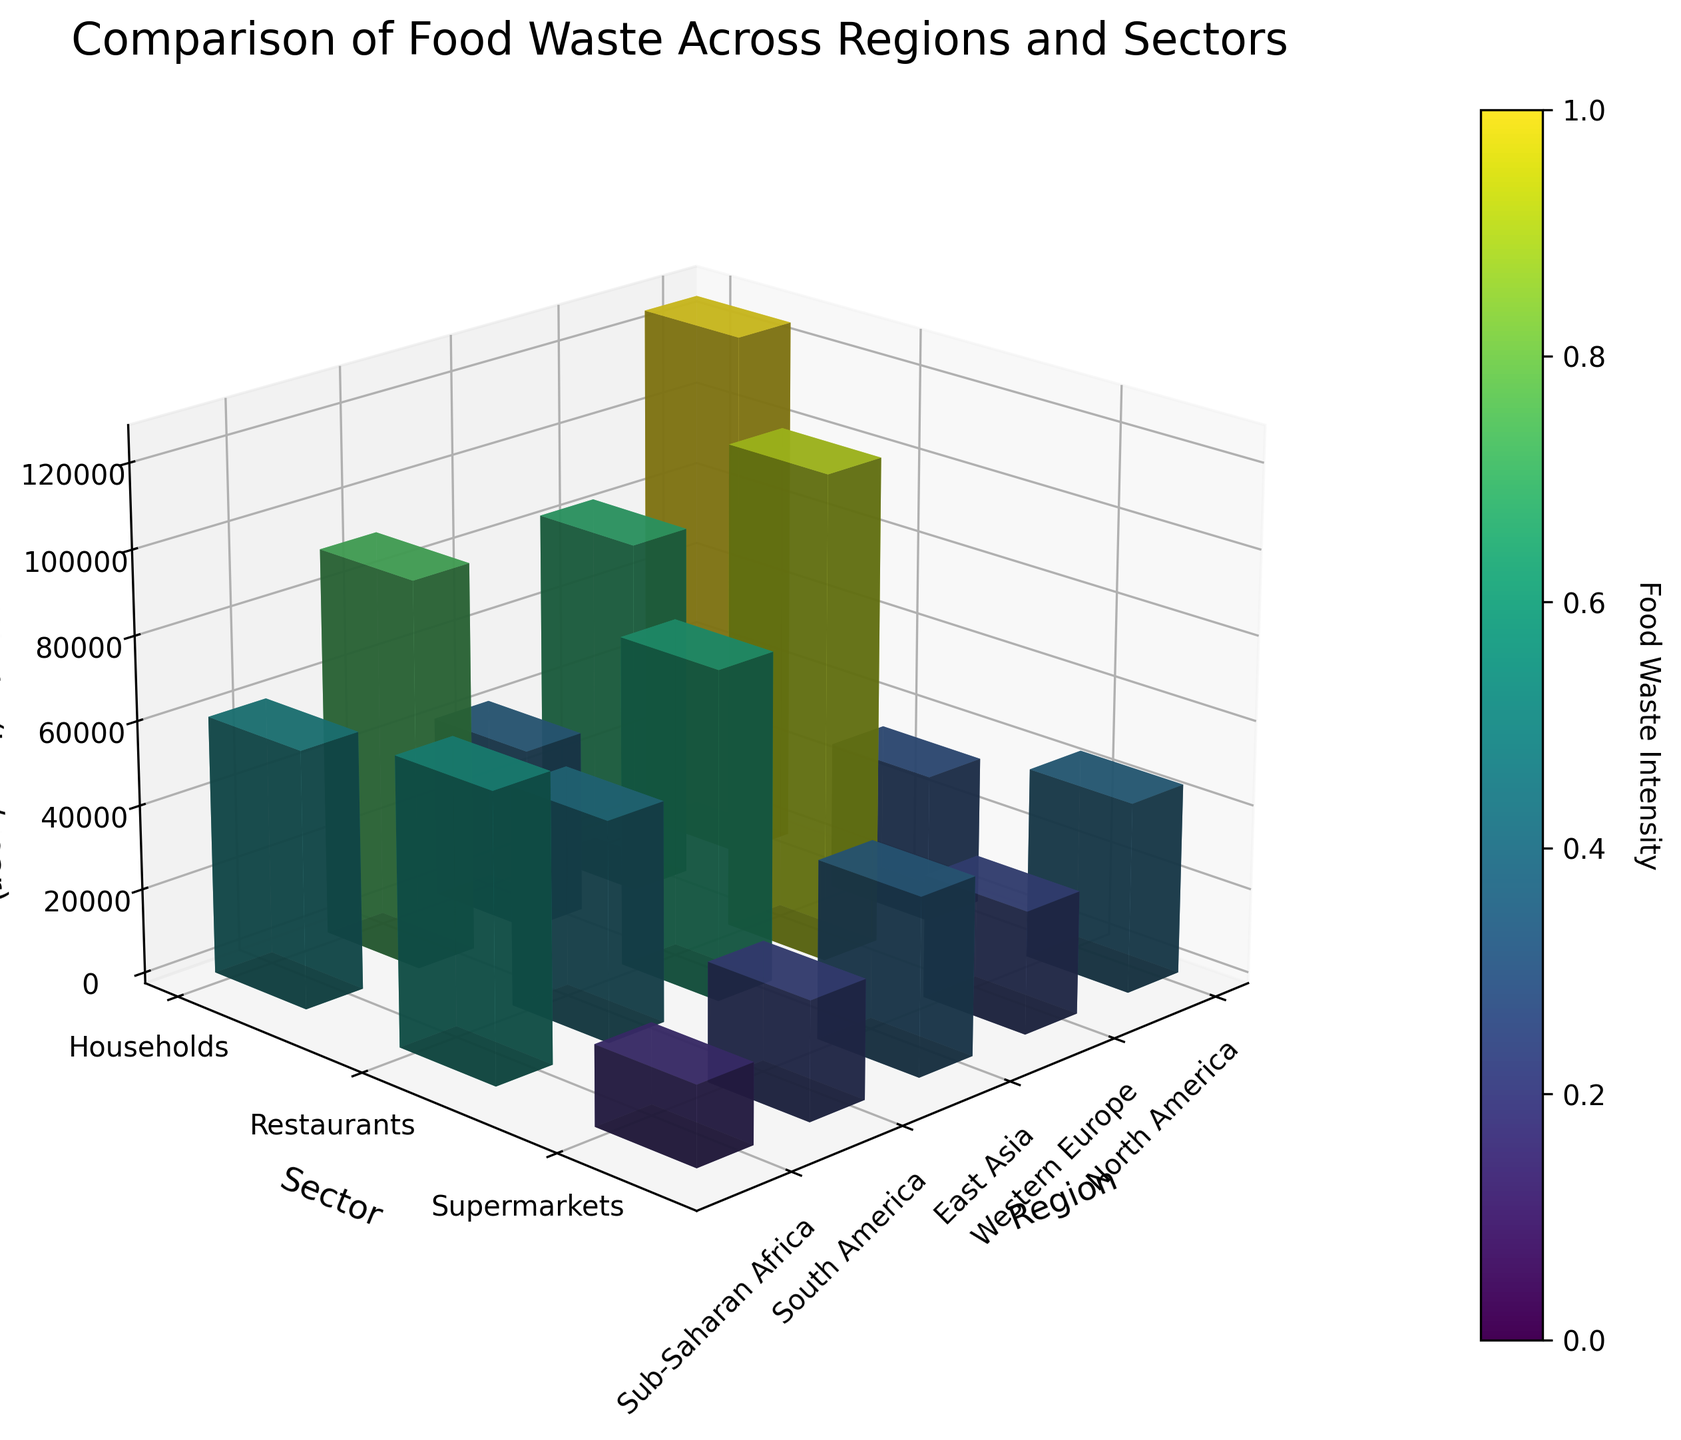Which sector in North America has the highest food waste? By examining the bars representing North America, the highest bar for North America corresponds to the Households sector.
Answer: Households What is the total amount of food waste in Western Europe? Adding the values for Western Europe: Households (92,000), Restaurants (61,000), and Supermarkets (35,000). The sum is 92,000 + 61,000 + 35,000 = 188,000 tons/year.
Answer: 188,000 tons/year Which region has the least food waste in the Supermarkets sector? By comparing the heights of the bars in the Supermarkets sector across regions, Sub-Saharan Africa has the smallest bar.
Answer: Sub-Saharan Africa How does food waste in East Asia's Restaurants compare to South America's Restaurants? Comparing the bars for the Restaurants sector in East Asia (78,000 tons/year) and South America (45,000 tons/year), East Asia has higher food waste.
Answer: East Asia has more What is the average amount of food waste generated by Households across all regions? Adding the food waste for Households in each region (126,000 + 92,000 + 115,000 + 68,000 + 42,000) and dividing by the number of regions (5): (443,000 / 5) = 88,600 tons/year.
Answer: 88,600 tons/year Do Supermarkets generally generate more or less food waste compared to Restaurants, across all regions? By visually comparing the bars for Supermarkets and Restaurants across all regions, it is evident that Restaurants generally have higher bars than Supermarkets.
Answer: Less What is the difference in food waste between the highest and lowest regions in the Households sector? The highest food waste in Households is in North America (126,000 tons/year), and the lowest is in Sub-Saharan Africa (42,000 tons/year). The difference is 126,000 - 42,000 = 84,000 tons/year.
Answer: 84,000 tons/year Which region shows the highest intensity of food waste in the Supermarkets sector according to the color gradient? The color gradient indicates intensity, and by comparing the colors of the bars for Supermarkets across regions, East Asia shows the highest intensity.
Answer: East Asia What is the combined food waste for Restaurants and Supermarkets in Sub-Saharan Africa? Adding the food waste for Restaurants (28,000 tons/year) and Supermarkets (19,000 tons/year) in Sub-Saharan Africa: 28,000 + 19,000 = 47,000 tons/year.
Answer: 47,000 tons/year 